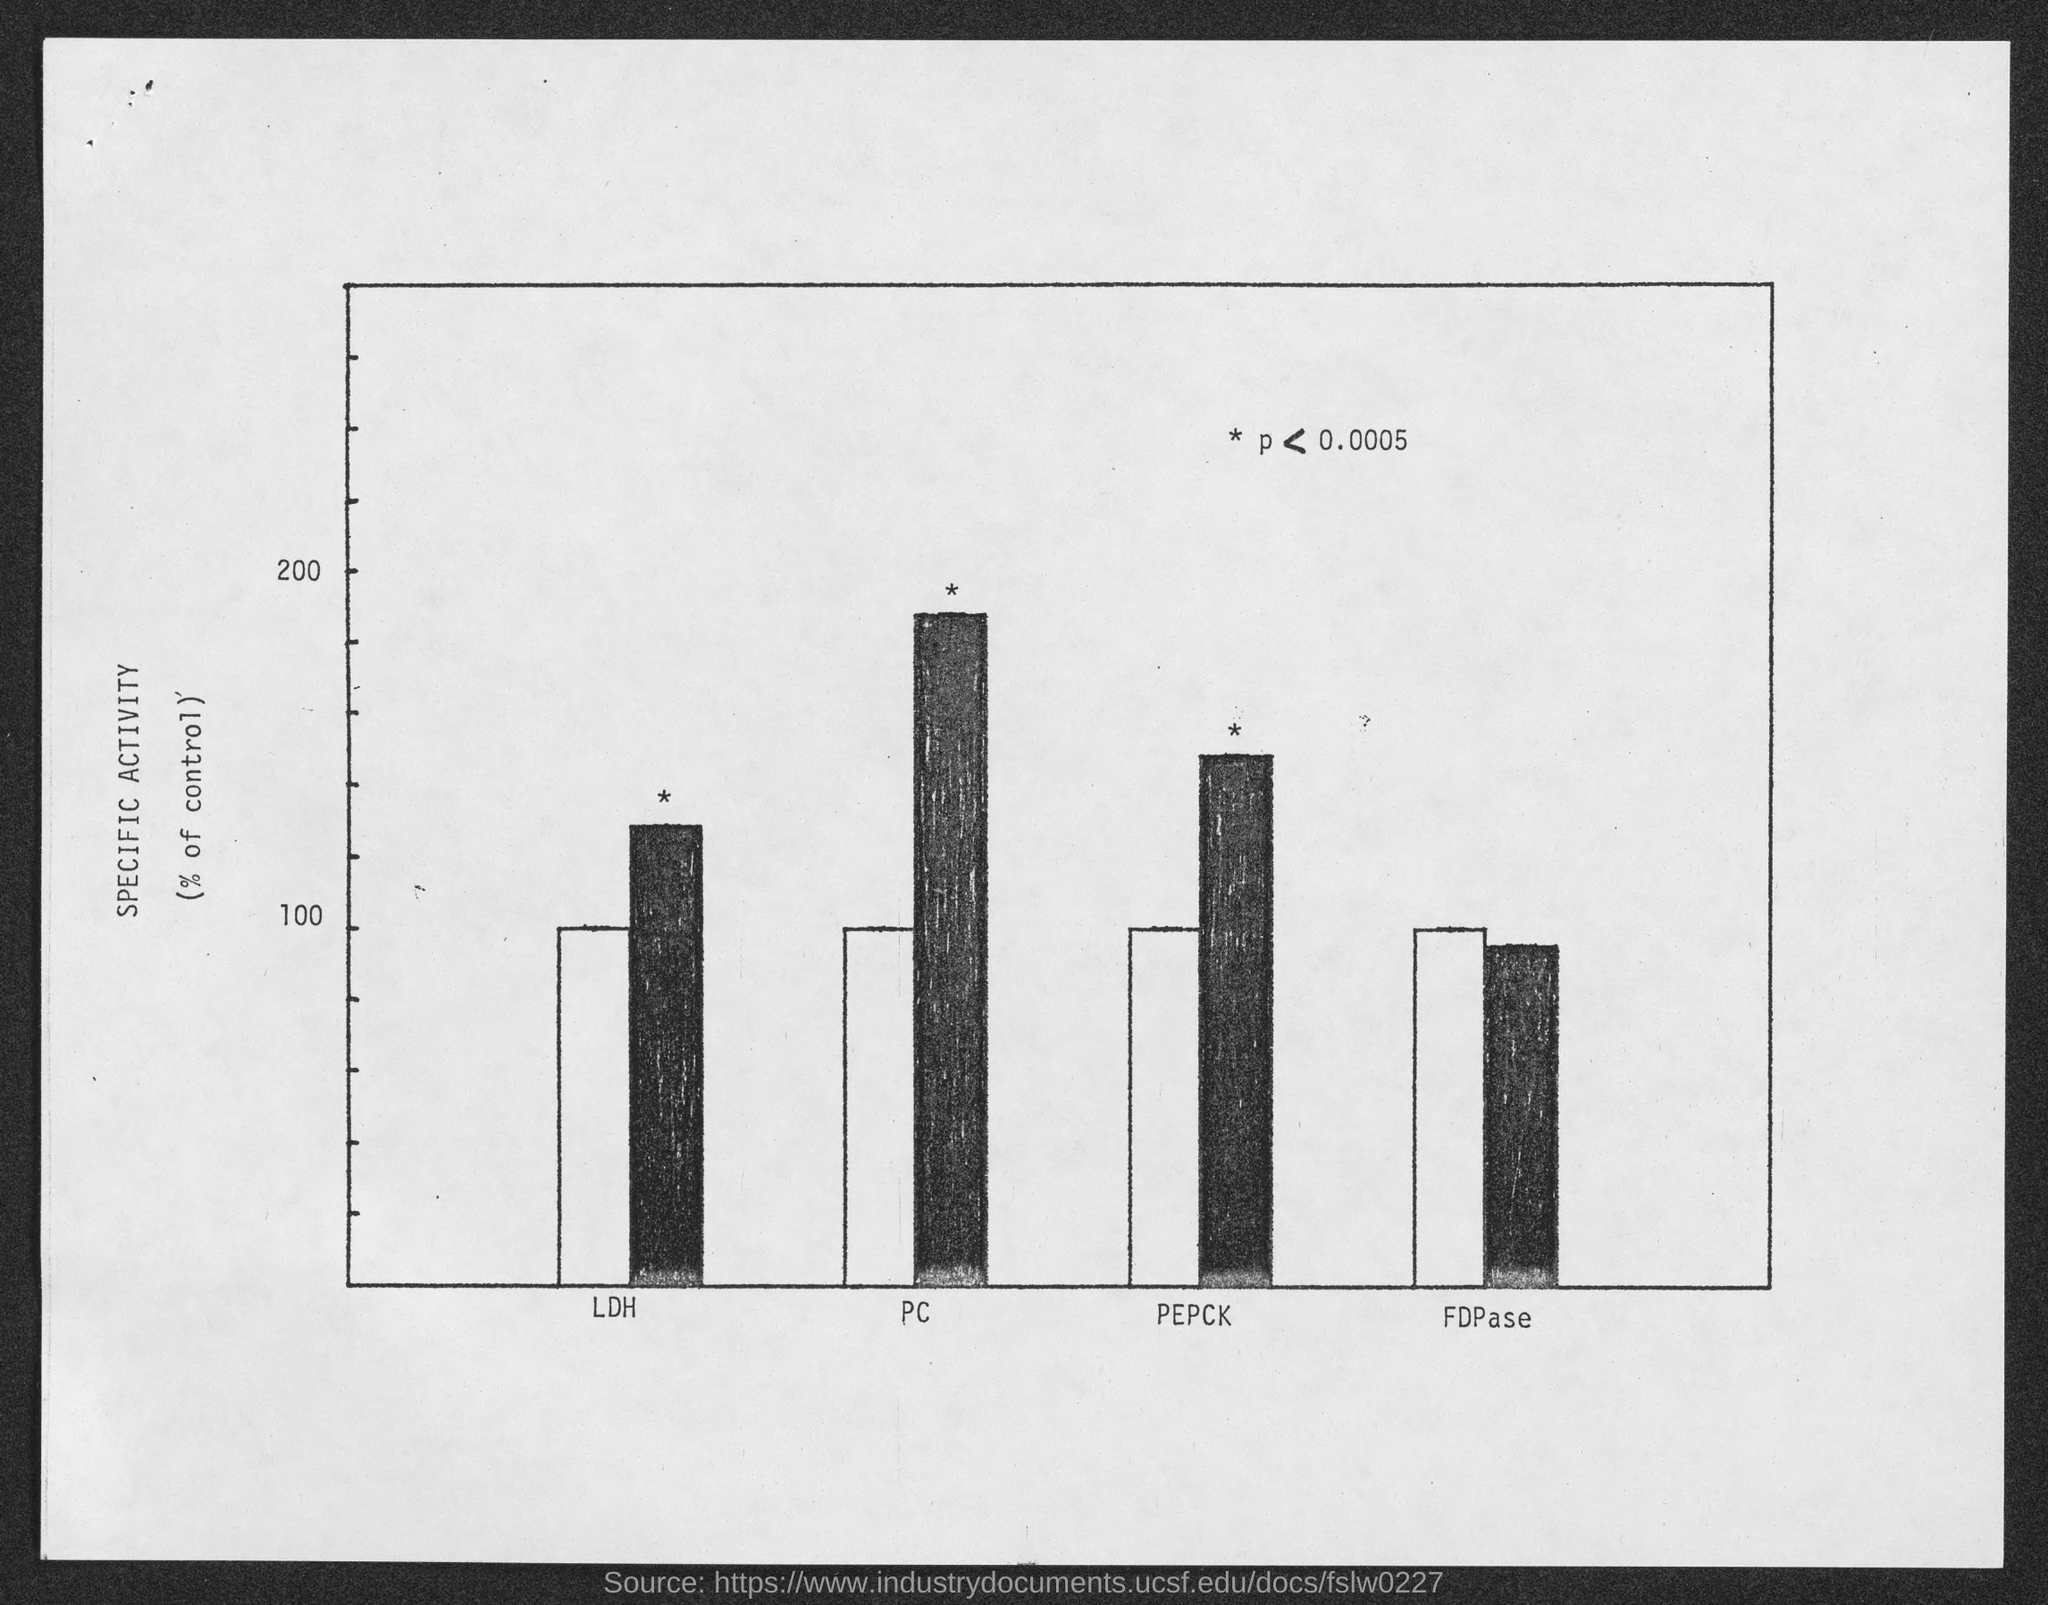What is shown in Y axis of the graph in Capital letters?
Provide a succinct answer. Specific Activity. What is the highest value written in the Y axis of the graph?
Your answer should be compact. 200. What is the lowest value written in the Y axis of the graph?
Ensure brevity in your answer.  100. What is the first word written in the X axis?
Keep it short and to the point. LDH. What is the last word written in the X axis?
Provide a short and direct response. FDPase. What is written inside the bracket below the word " SPECIFIC ACTIVITY" in the Y axis?
Your answer should be compact. % of control. What is the second word written in the X axis?
Keep it short and to the point. PC. What is the third word written in the X axis?
Provide a succinct answer. PEPCK. 